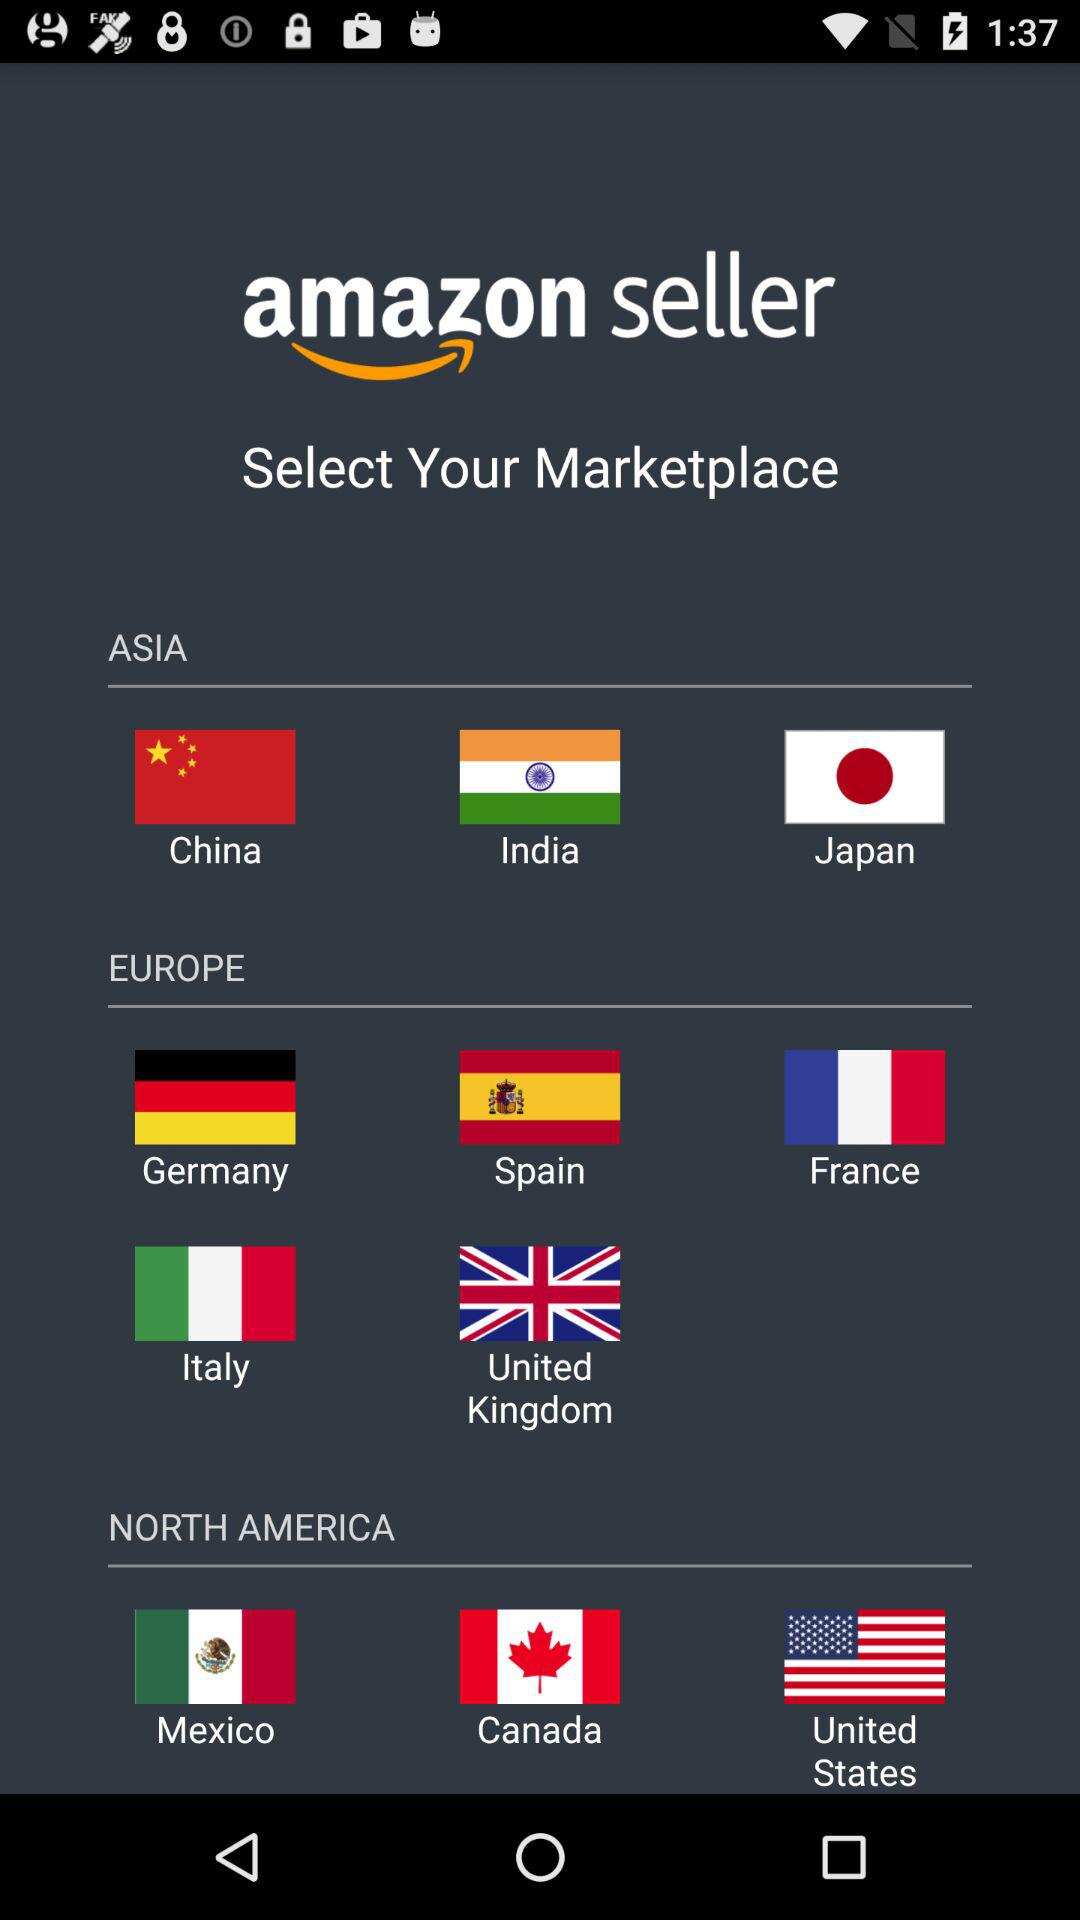Which marketplace is selected?
When the provided information is insufficient, respond with <no answer>. <no answer> 